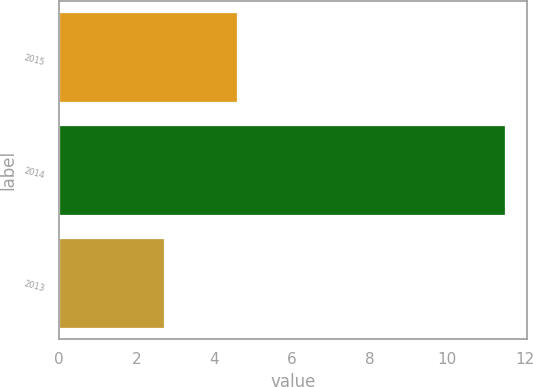Convert chart to OTSL. <chart><loc_0><loc_0><loc_500><loc_500><bar_chart><fcel>2015<fcel>2014<fcel>2013<nl><fcel>4.6<fcel>11.5<fcel>2.7<nl></chart> 